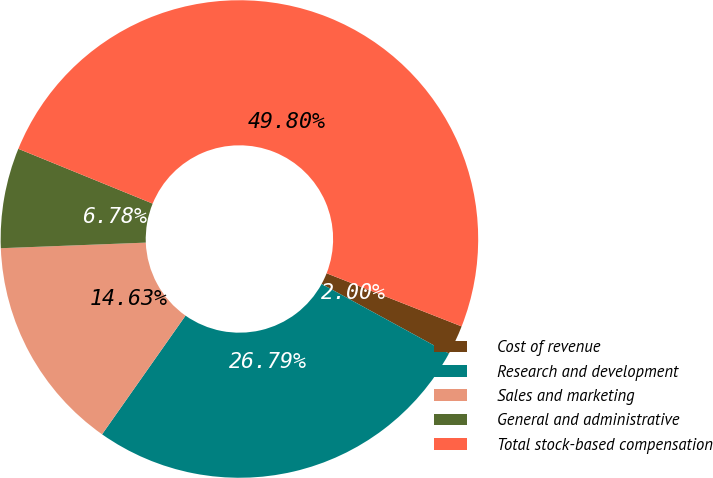<chart> <loc_0><loc_0><loc_500><loc_500><pie_chart><fcel>Cost of revenue<fcel>Research and development<fcel>Sales and marketing<fcel>General and administrative<fcel>Total stock-based compensation<nl><fcel>2.0%<fcel>26.79%<fcel>14.63%<fcel>6.78%<fcel>49.8%<nl></chart> 